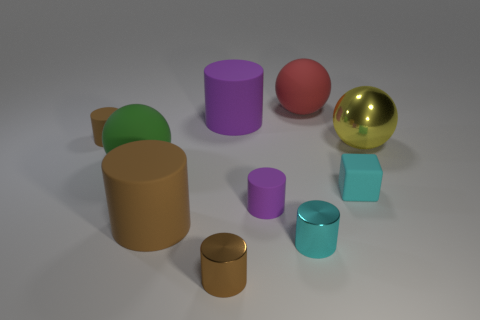How many other objects are there of the same shape as the red rubber object?
Ensure brevity in your answer.  2. There is another shiny thing that is the same size as the red thing; what is its color?
Make the answer very short. Yellow. What number of cylinders are either brown rubber objects or green things?
Your answer should be compact. 2. How many big red metallic spheres are there?
Keep it short and to the point. 0. There is a tiny brown rubber object; is it the same shape as the cyan thing in front of the tiny cyan rubber cube?
Offer a very short reply. Yes. There is a cylinder that is the same color as the cube; what size is it?
Offer a terse response. Small. What number of things are green rubber things or gray matte objects?
Give a very brief answer. 1. There is a tiny brown object that is in front of the shiny thing that is behind the cyan rubber block; what is its shape?
Your answer should be compact. Cylinder. There is a object in front of the cyan cylinder; is it the same shape as the big yellow thing?
Keep it short and to the point. No. What size is the other purple object that is the same material as the tiny purple object?
Give a very brief answer. Large. 